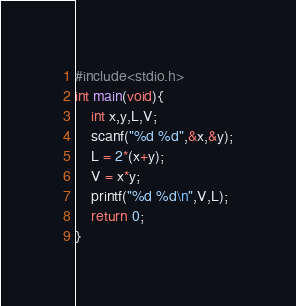Convert code to text. <code><loc_0><loc_0><loc_500><loc_500><_C_>#include<stdio.h>
int main(void){
    int x,y,L,V;
    scanf("%d %d",&x,&y);
    L = 2*(x+y);
    V = x*y;
    printf("%d %d\n",V,L);
    return 0;
}</code> 